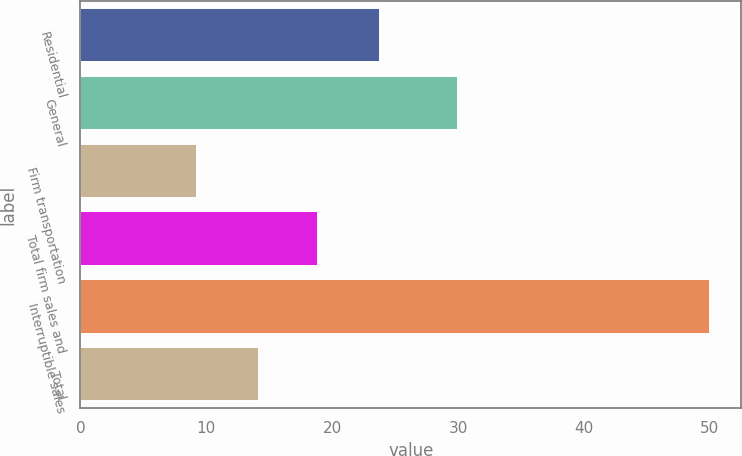<chart> <loc_0><loc_0><loc_500><loc_500><bar_chart><fcel>Residential<fcel>General<fcel>Firm transportation<fcel>Total firm sales and<fcel>Interruptible sales<fcel>Total<nl><fcel>23.8<fcel>30<fcel>9.3<fcel>18.9<fcel>50<fcel>14.2<nl></chart> 